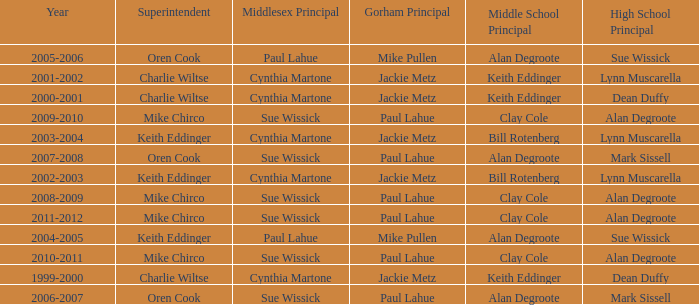Who were the middle school principal(s) in 2010-2011? Clay Cole. 